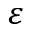<formula> <loc_0><loc_0><loc_500><loc_500>\varepsilon</formula> 